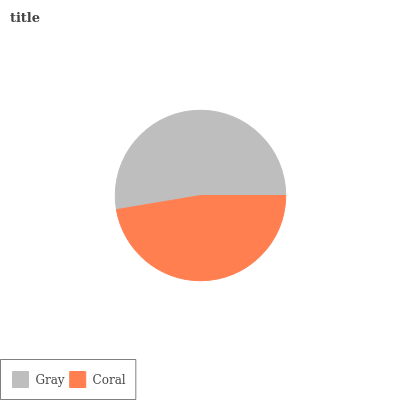Is Coral the minimum?
Answer yes or no. Yes. Is Gray the maximum?
Answer yes or no. Yes. Is Coral the maximum?
Answer yes or no. No. Is Gray greater than Coral?
Answer yes or no. Yes. Is Coral less than Gray?
Answer yes or no. Yes. Is Coral greater than Gray?
Answer yes or no. No. Is Gray less than Coral?
Answer yes or no. No. Is Gray the high median?
Answer yes or no. Yes. Is Coral the low median?
Answer yes or no. Yes. Is Coral the high median?
Answer yes or no. No. Is Gray the low median?
Answer yes or no. No. 